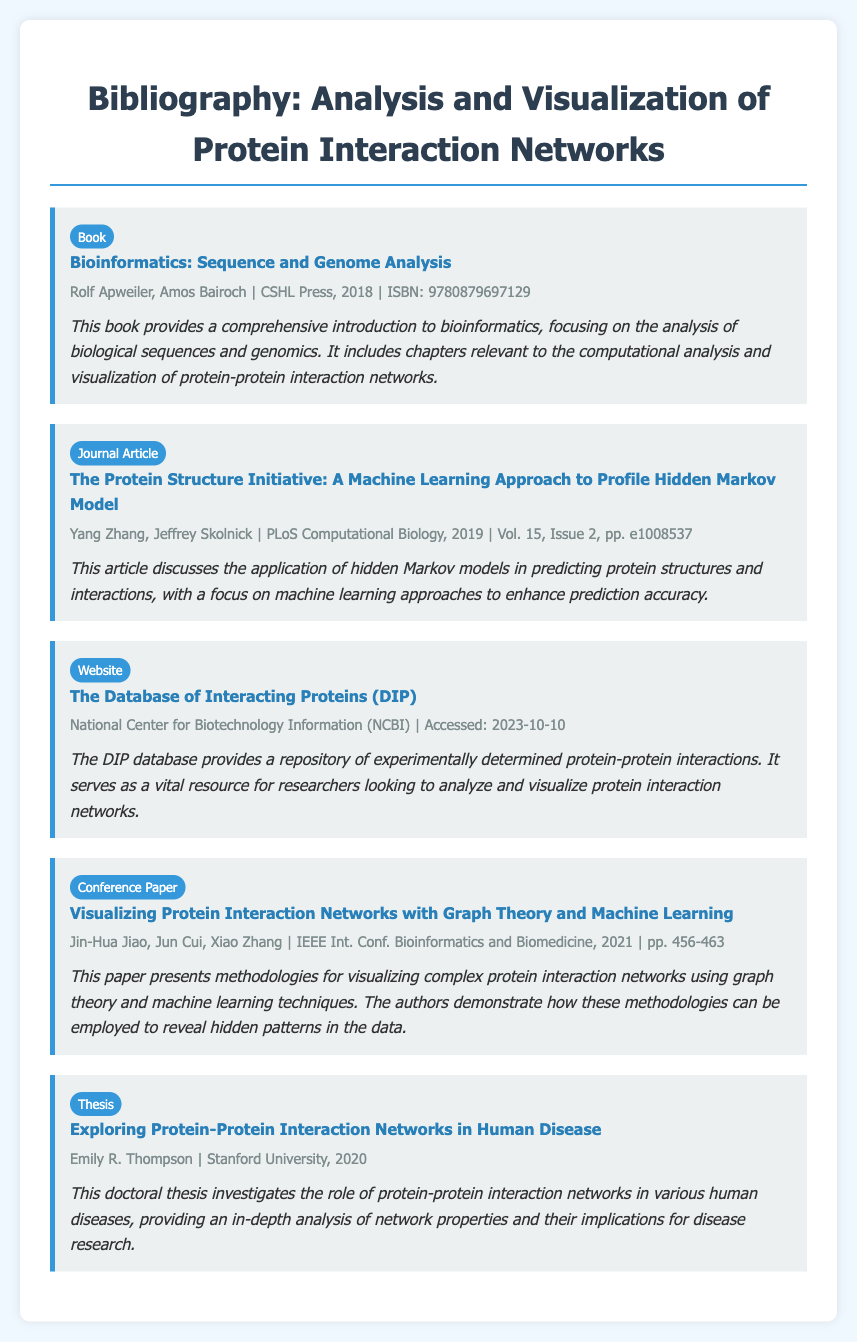what is the title of the book authored by Rolf Apweiler and Amos Bairoch? The title of the book is provided in the entry for the book and is "Bioinformatics: Sequence and Genome Analysis."
Answer: Bioinformatics: Sequence and Genome Analysis who published the journal article by Yang Zhang and Jeffrey Skolnick? The publication information in the entry specifies that it was published in PLoS Computational Biology.
Answer: PLoS Computational Biology what year was the thesis by Emily R. Thompson published? The entry for the thesis indicates that it was published in the year 2020.
Answer: 2020 what is the main focus of the conference paper by Jin-Hua Jiao and colleagues? The title and description suggest that it focuses on visualizing protein interaction networks using graph theory and machine learning.
Answer: Visualizing Protein Interaction Networks with Graph Theory and Machine Learning which organization manages the Database of Interacting Proteins? The entry specifies that it is managed by the National Center for Biotechnology Information (NCBI).
Answer: National Center for Biotechnology Information (NCBI) how many entries are listed in the bibliography? The document contains a total of five entries listed under different categories.
Answer: 5 what is the primary method discussed in the article by Yang Zhang and Jeffrey Skolnick? The description highlights the use of hidden Markov models as the primary method for predicting protein structures and interactions.
Answer: Hidden Markov models in which year was the conference paper presented? The entry specifies the year of the conference as 2021, when the paper was presented.
Answer: 2021 what type of document is "Exploring Protein-Protein Interaction Networks in Human Disease"? The entry classifies this document type as a thesis.
Answer: Thesis 